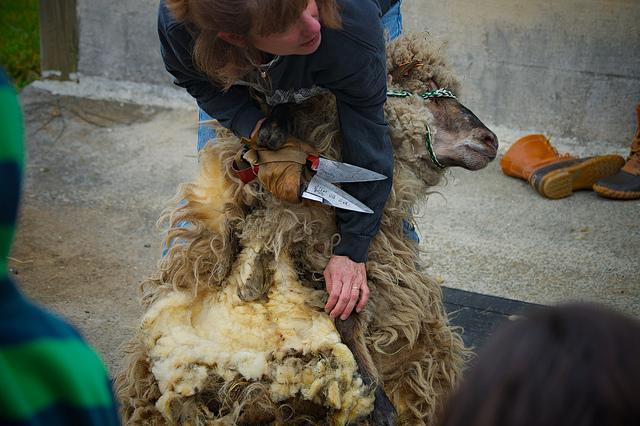How many scissors are visible?
Give a very brief answer. 1. How many people are in the photo?
Give a very brief answer. 3. 